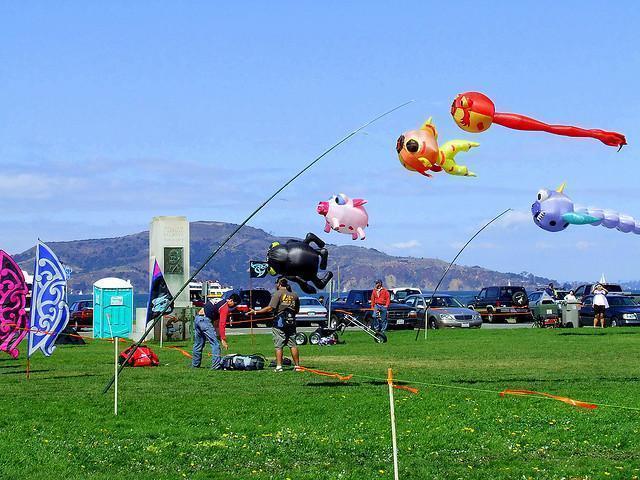Where can you reasonably go to the bathroom here?
Answer the question by selecting the correct answer among the 4 following choices and explain your choice with a short sentence. The answer should be formatted with the following format: `Answer: choice
Rationale: rationale.`
Options: Behind tree, male restroom, outhouse, female restroom. Answer: outhouse.
Rationale: In far distance is a blue receptacle. it is the only place because its outside to go bathroom. 